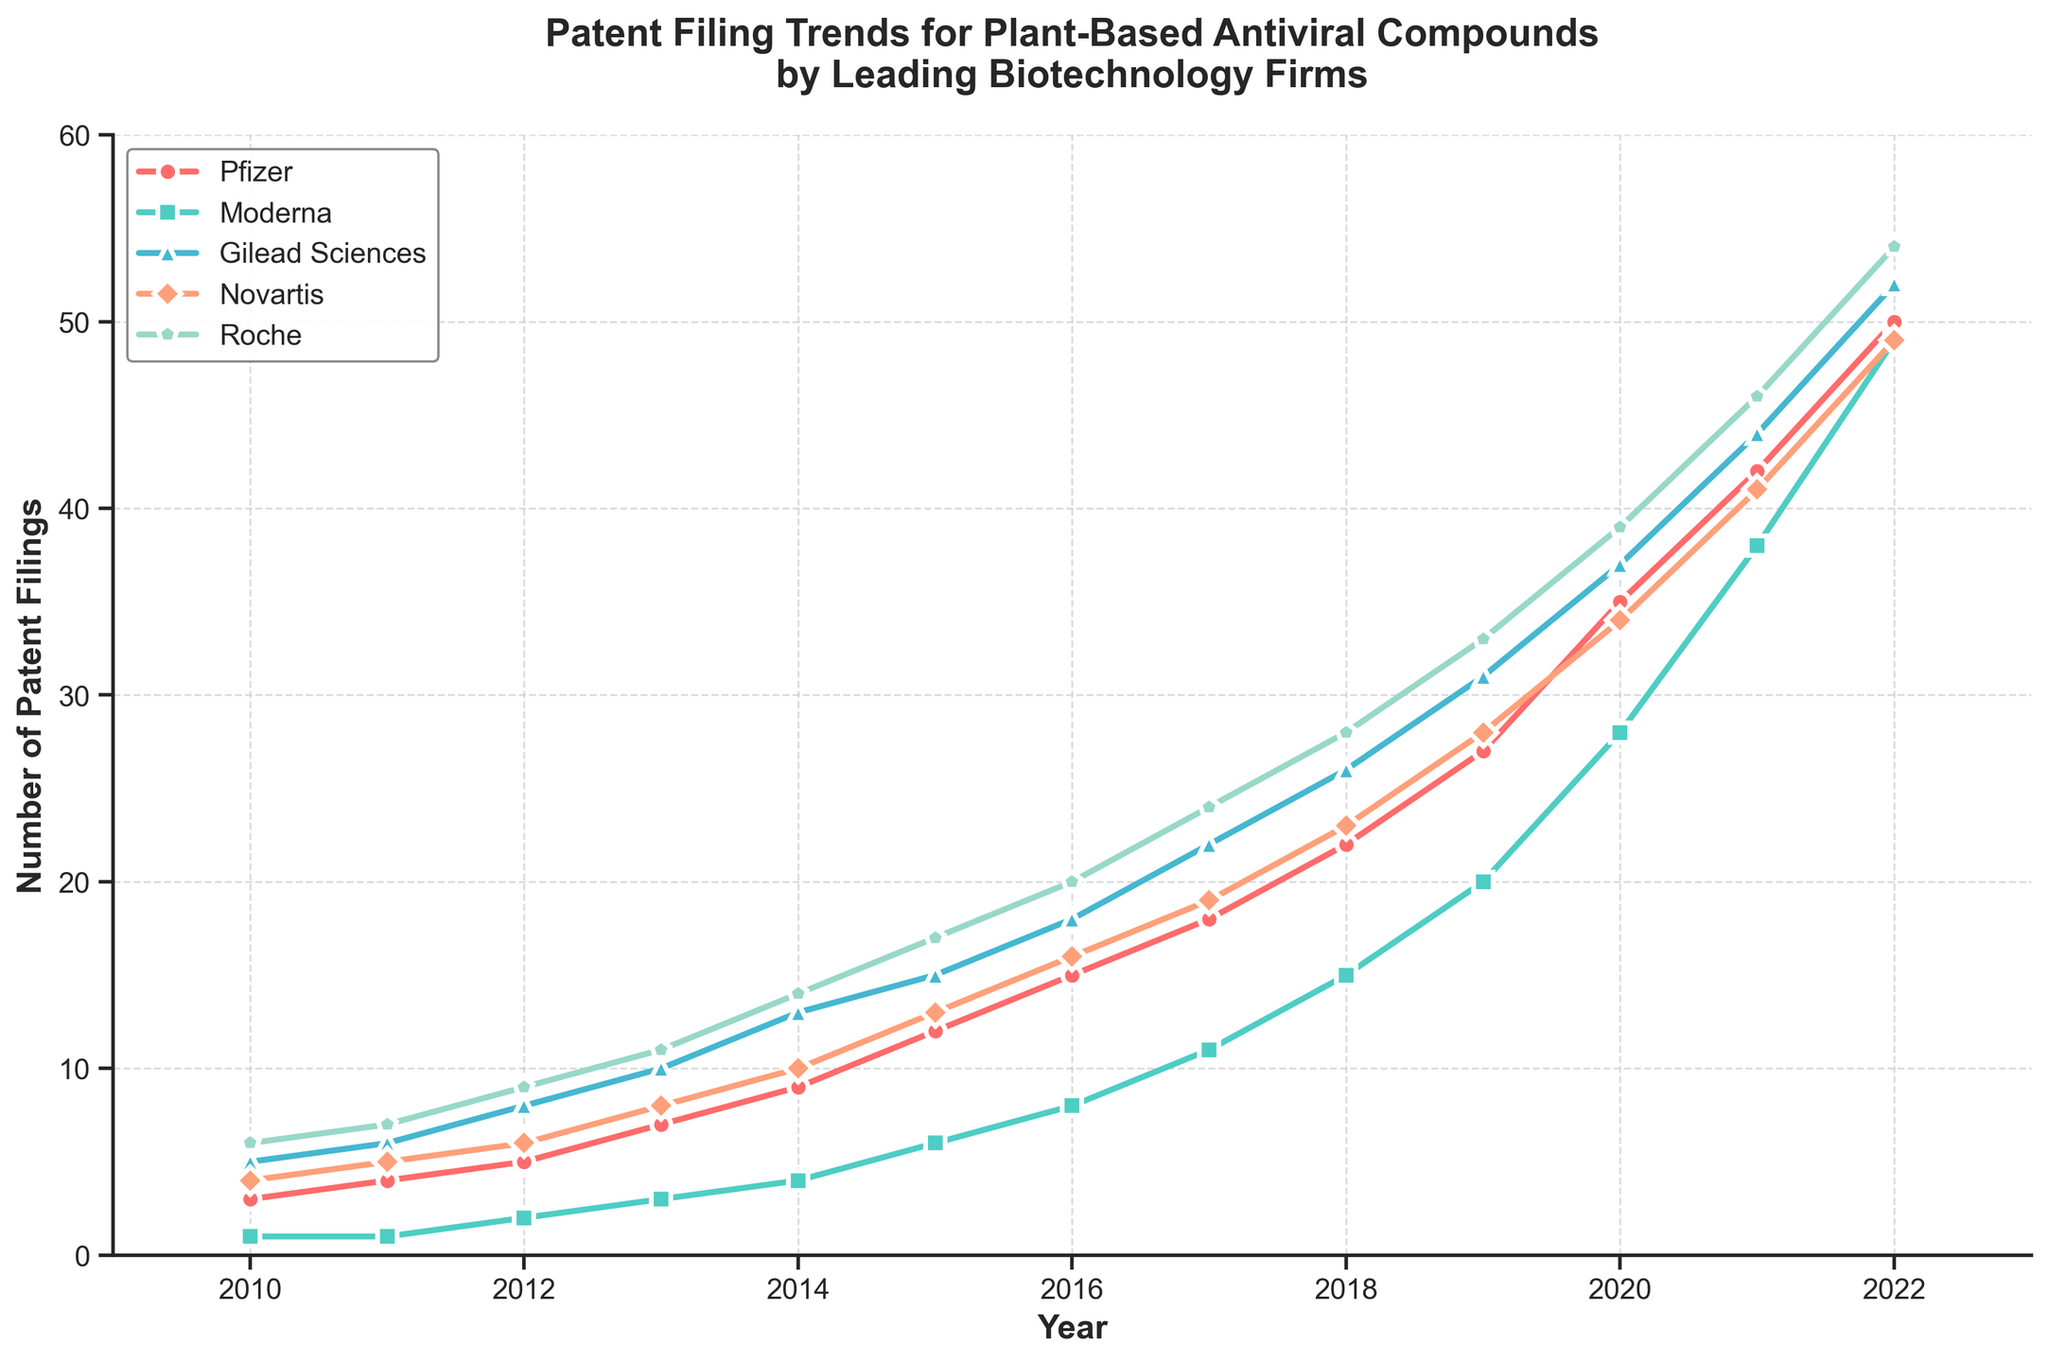What year did Pfizer have the highest number of patent filings? Pfizer's line on the chart is the red line with circle markers. The peak occurs in 2022.
Answer: 2022 Which company had the largest increase in patent filings between 2010 and 2022? The increase in patent filings for each company is calculated as the difference between their values in 2022 and 2010. Pfizer: 50-3=47, Moderna: 49-1=48, Gilead Sciences: 52-5=47, Novartis: 49-4=45, Roche: 54-6=48. Both Moderna and Roche had the largest increase of 48.
Answer: Moderna and Roche How many more patents did Roche file compared to Gilead Sciences in 2022? The figure shows the number of patent filings in 2022 for Roche (54) and Gilead Sciences (52). The difference is 54 - 52.
Answer: 2 What is the average number of patents filed by Novartis over the years shown? Sum the values for Novartis from 2010 to 2022 and divide by the number of years (13). The sum is 4+5+6+8+10+13+16+19+23+28+34+41+49=256. The average is 256/13.
Answer: 19.69 (approximately) Which year did all the companies show an increase in patent filings compared to the previous year? By examining the lines for each company, it can be observed that all companies' lines rise from 2011 to 2012 and from 2014 to 2015.
Answer: 2012 and 2015 Which company filed the least number of patents in 2015, and how many patents did they file? The chart indicates that Moderna, represented by the green line with square markers, had the least filings in 2015, with 6 patents.
Answer: Moderna, 6 Between 2016 and 2022, which company had the most consistent (smallest year-to-year changes) annual increase in patent filings? Consistency can be evaluated by examining the smoothness and incremental increases in the lines. Pfizer (red line with circle markers) shows consistent annual increase without sharp jumps.
Answer: Pfizer What is the total number of patents filed by all companies in 2020? Sum the number of patents filed by each company in 2020: 35 (Pfizer) + 28 (Moderna) + 37 (Gilead Sciences) + 34 (Novartis) + 39 (Roche) = 173.
Answer: 173 Which company showed the most significant surge in patent filings between two consecutive years? Identify those years. The graph shows the biggest surge for Moderna's patents (green line with square markers) between 2020 and 2021, increasing from 28 to 38, a surge of 10.
Answer: Moderna, 2020-2021 